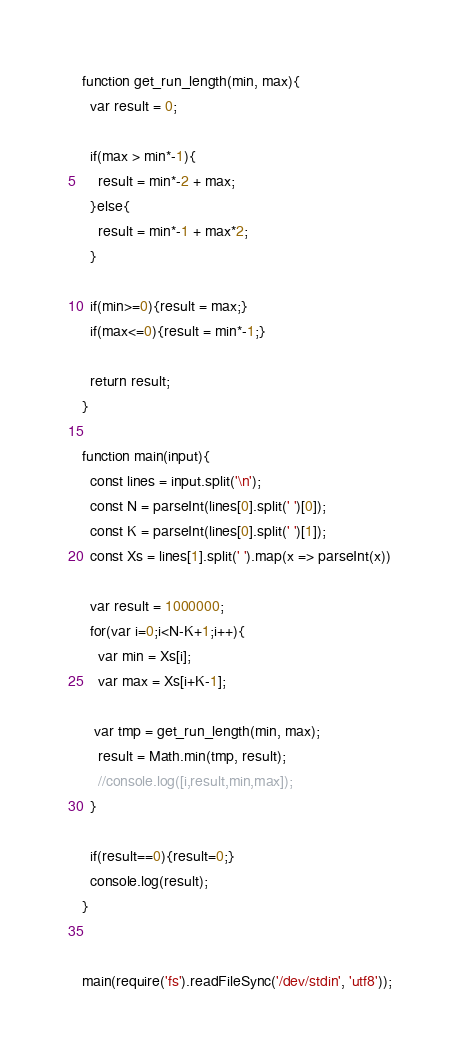<code> <loc_0><loc_0><loc_500><loc_500><_JavaScript_>function get_run_length(min, max){
  var result = 0;

  if(max > min*-1){
    result = min*-2 + max;
  }else{
    result = min*-1 + max*2;
  }

  if(min>=0){result = max;}
  if(max<=0){result = min*-1;}

  return result;
}

function main(input){
  const lines = input.split('\n');
  const N = parseInt(lines[0].split(' ')[0]);
  const K = parseInt(lines[0].split(' ')[1]);
  const Xs = lines[1].split(' ').map(x => parseInt(x))

  var result = 1000000;
  for(var i=0;i<N-K+1;i++){
    var min = Xs[i];
    var max = Xs[i+K-1];

   var tmp = get_run_length(min, max);
    result = Math.min(tmp, result);
    //console.log([i,result,min,max]);
  }

  if(result==0){result=0;}
  console.log(result);
}


main(require('fs').readFileSync('/dev/stdin', 'utf8'));
</code> 